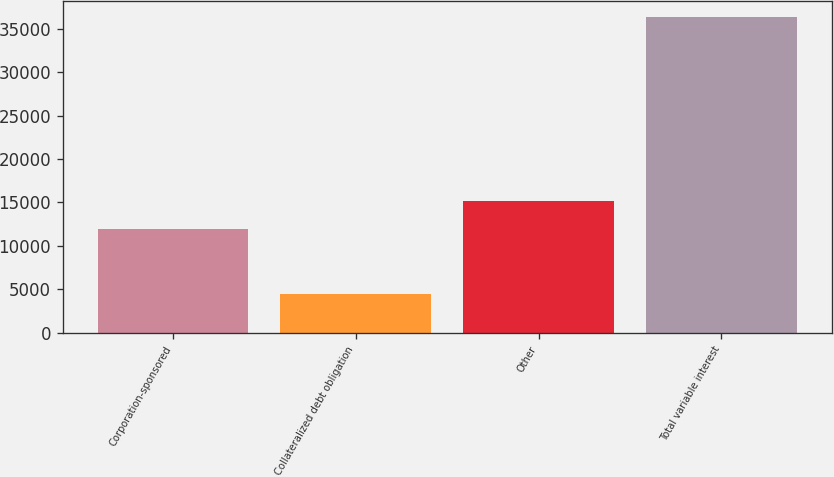Convert chart. <chart><loc_0><loc_0><loc_500><loc_500><bar_chart><fcel>Corporation-sponsored<fcel>Collateralized debt obligation<fcel>Other<fcel>Total variable interest<nl><fcel>11944<fcel>4464<fcel>15139.1<fcel>36415<nl></chart> 